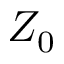<formula> <loc_0><loc_0><loc_500><loc_500>Z _ { 0 }</formula> 